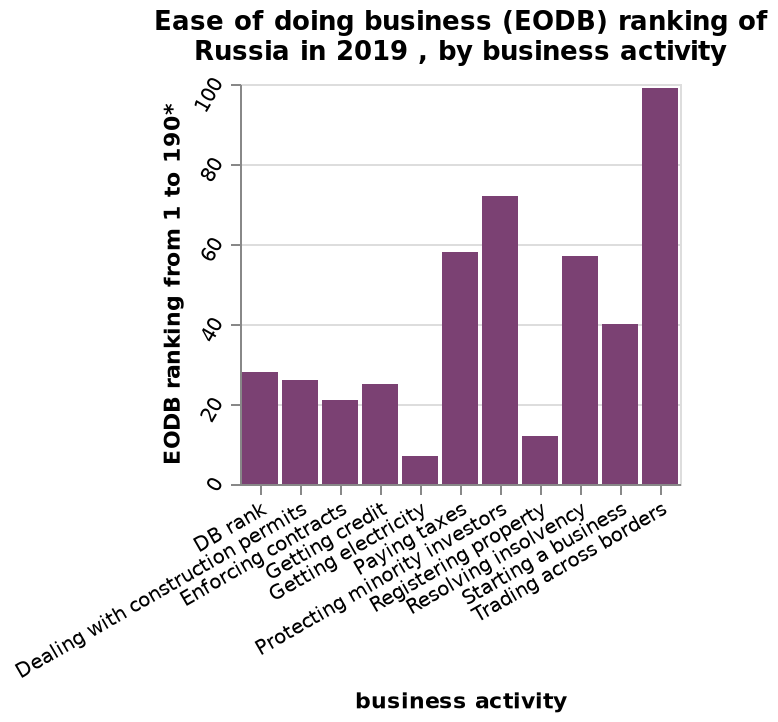<image>
How would you rank trading across borders as a business activity?  Trading across borders is ranked as the easiest business activity. Offer a thorough analysis of the image. Trading across borders has the highest EODB ranking. What is the x-axis label on the bar plot?  The x-axis is labeled "Business activity". What is the maximum value on the y-axis scale? The maximum value on the y-axis scale is 100. What activity is ranked as the easiest business activity?  Trading across borders. What is the level of difficulty associated with trading across borders? Trading across borders is ranked as the easiest business activity. 